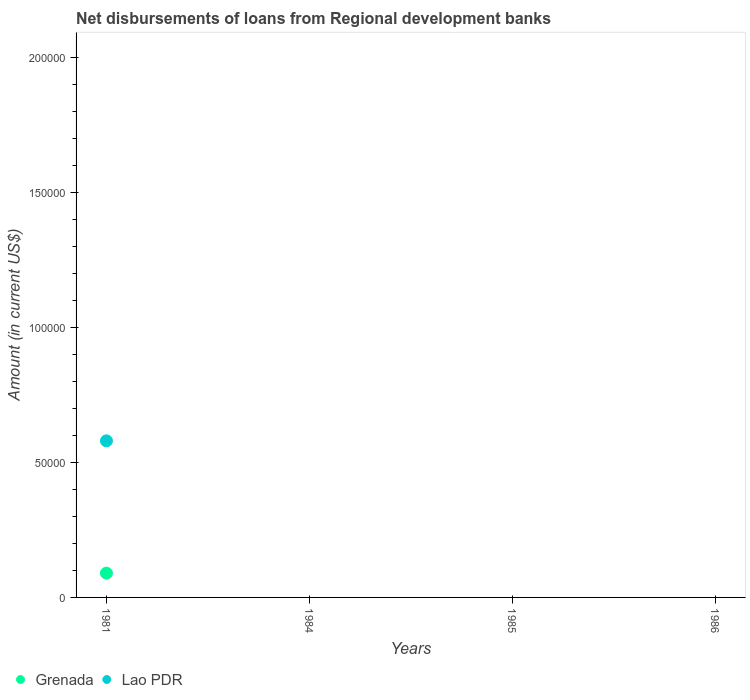Is the number of dotlines equal to the number of legend labels?
Give a very brief answer. No. What is the amount of disbursements of loans from regional development banks in Lao PDR in 1981?
Give a very brief answer. 5.80e+04. Across all years, what is the maximum amount of disbursements of loans from regional development banks in Grenada?
Your answer should be compact. 9000. What is the total amount of disbursements of loans from regional development banks in Lao PDR in the graph?
Your answer should be very brief. 5.80e+04. What is the difference between the amount of disbursements of loans from regional development banks in Grenada in 1984 and the amount of disbursements of loans from regional development banks in Lao PDR in 1981?
Offer a very short reply. -5.80e+04. What is the average amount of disbursements of loans from regional development banks in Lao PDR per year?
Your response must be concise. 1.45e+04. In the year 1981, what is the difference between the amount of disbursements of loans from regional development banks in Lao PDR and amount of disbursements of loans from regional development banks in Grenada?
Your answer should be compact. 4.90e+04. What is the difference between the highest and the lowest amount of disbursements of loans from regional development banks in Lao PDR?
Your response must be concise. 5.80e+04. Does the amount of disbursements of loans from regional development banks in Lao PDR monotonically increase over the years?
Keep it short and to the point. No. How many dotlines are there?
Ensure brevity in your answer.  2. How many years are there in the graph?
Keep it short and to the point. 4. Does the graph contain any zero values?
Offer a terse response. Yes. Does the graph contain grids?
Make the answer very short. No. Where does the legend appear in the graph?
Give a very brief answer. Bottom left. What is the title of the graph?
Provide a short and direct response. Net disbursements of loans from Regional development banks. What is the label or title of the Y-axis?
Offer a very short reply. Amount (in current US$). What is the Amount (in current US$) in Grenada in 1981?
Your answer should be compact. 9000. What is the Amount (in current US$) in Lao PDR in 1981?
Your response must be concise. 5.80e+04. What is the Amount (in current US$) in Grenada in 1984?
Ensure brevity in your answer.  0. What is the Amount (in current US$) in Lao PDR in 1984?
Your response must be concise. 0. What is the Amount (in current US$) of Grenada in 1985?
Give a very brief answer. 0. What is the Amount (in current US$) of Grenada in 1986?
Your answer should be very brief. 0. Across all years, what is the maximum Amount (in current US$) in Grenada?
Keep it short and to the point. 9000. Across all years, what is the maximum Amount (in current US$) in Lao PDR?
Provide a short and direct response. 5.80e+04. Across all years, what is the minimum Amount (in current US$) in Grenada?
Give a very brief answer. 0. What is the total Amount (in current US$) in Grenada in the graph?
Your answer should be compact. 9000. What is the total Amount (in current US$) of Lao PDR in the graph?
Offer a very short reply. 5.80e+04. What is the average Amount (in current US$) of Grenada per year?
Your answer should be very brief. 2250. What is the average Amount (in current US$) in Lao PDR per year?
Offer a terse response. 1.45e+04. In the year 1981, what is the difference between the Amount (in current US$) in Grenada and Amount (in current US$) in Lao PDR?
Make the answer very short. -4.90e+04. What is the difference between the highest and the lowest Amount (in current US$) of Grenada?
Provide a succinct answer. 9000. What is the difference between the highest and the lowest Amount (in current US$) in Lao PDR?
Make the answer very short. 5.80e+04. 